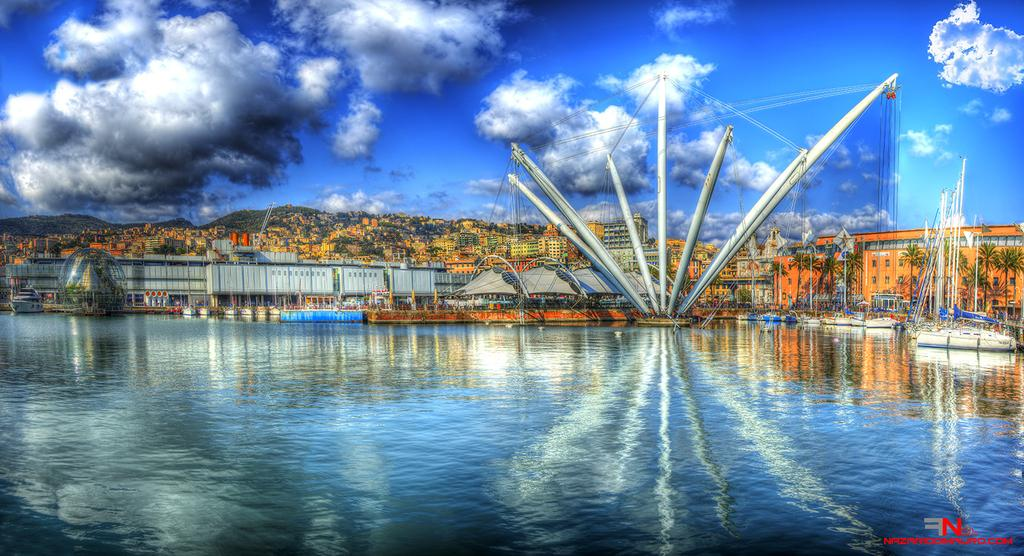What is the main feature of the image? There is a big river in the image. What is located in the river? There is a ship parked in the river. What else can be seen in the image besides the river and the ship? There are buildings, trees, and mountains visible in the image. What type of toothpaste is being used to clean the ship's windows in the image? There is no toothpaste present in the image, and the ship's windows are not being cleaned. How many eyes can be seen on the trees in the image? Trees do not have eyes, so this question cannot be answered based on the information provided. 